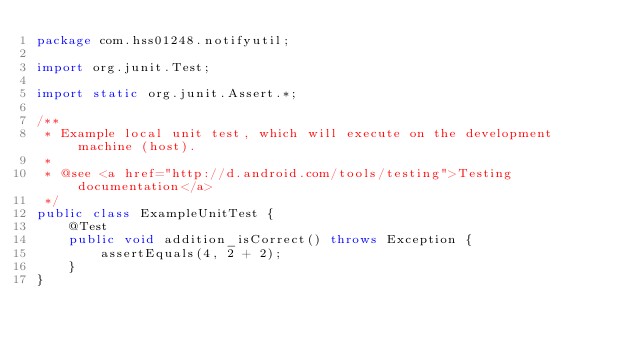<code> <loc_0><loc_0><loc_500><loc_500><_Java_>package com.hss01248.notifyutil;

import org.junit.Test;

import static org.junit.Assert.*;

/**
 * Example local unit test, which will execute on the development machine (host).
 *
 * @see <a href="http://d.android.com/tools/testing">Testing documentation</a>
 */
public class ExampleUnitTest {
    @Test
    public void addition_isCorrect() throws Exception {
        assertEquals(4, 2 + 2);
    }
}</code> 